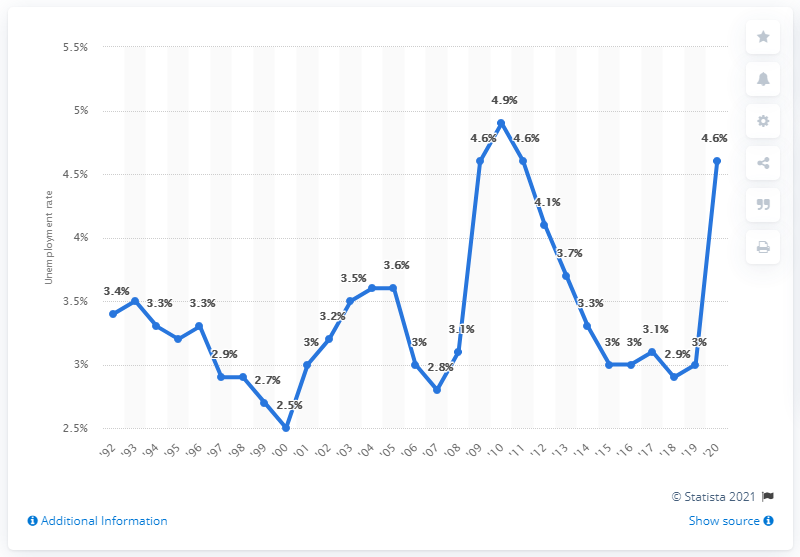Highlight a few significant elements in this photo. In 2020, the unemployment rate in South Dakota was 4.6%. In 2010, South Dakota experienced a high unemployment rate of 4.9%. 